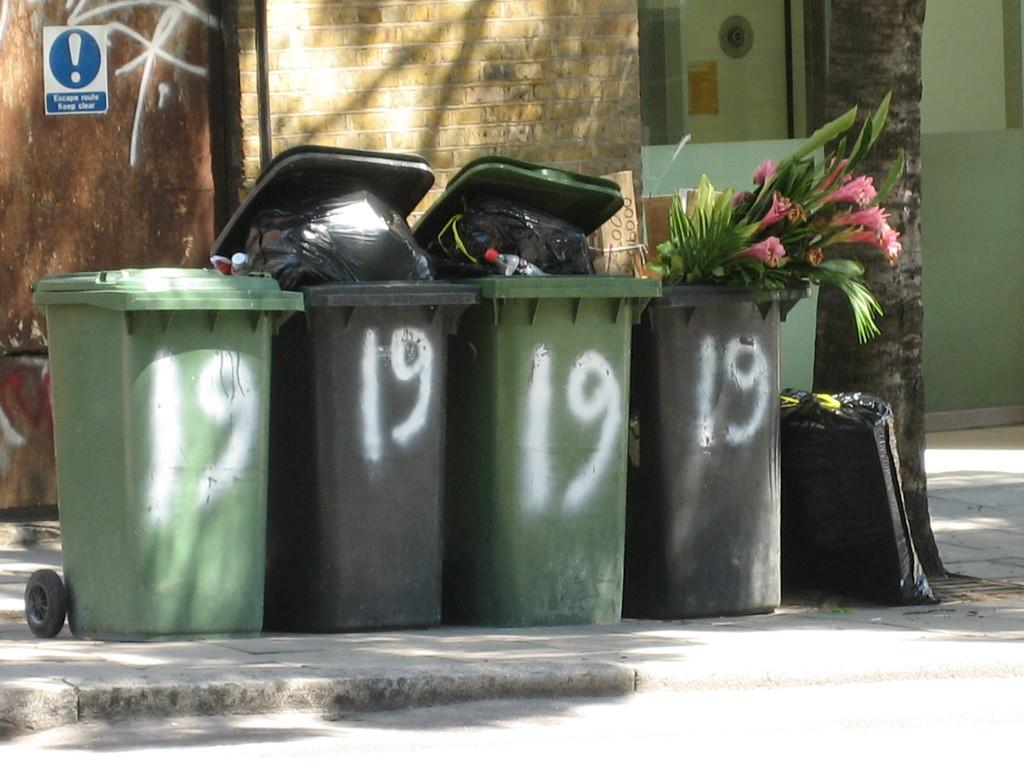<image>
Create a compact narrative representing the image presented. The number 19 on a bunch of different trashbags 